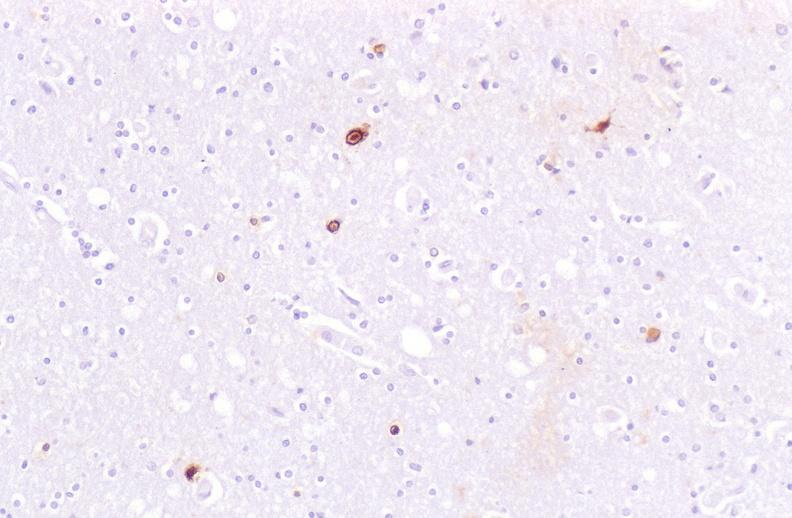what does this image show?
Answer the question using a single word or phrase. Brain 